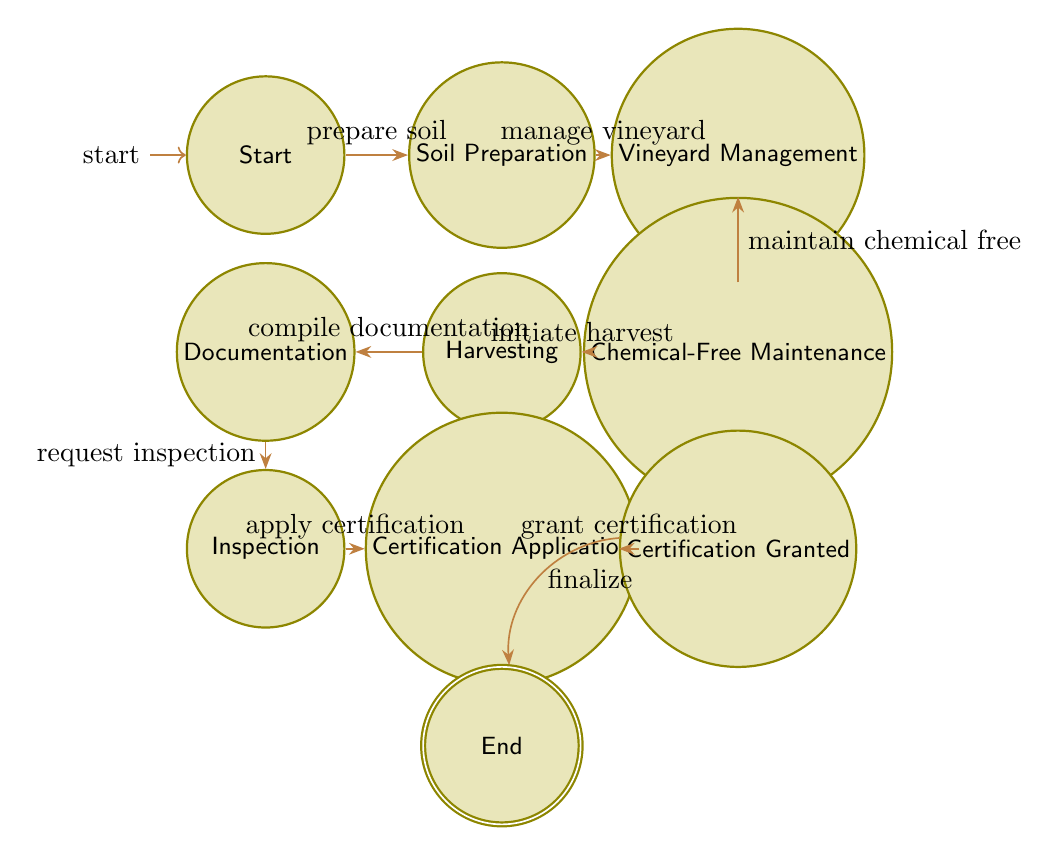What is the starting state of the workflow? The diagram indicates the initial state is labeled "Start," which is the first node in the workflow.
Answer: Start How many states are there in total? By counting all the nodes in the diagram, we find there are ten distinct states representing various steps in the organic certification compliance workflow.
Answer: 10 What follows "Chemical-Free Maintenance" in the workflow? The transition from "Chemical-Free Maintenance" leads to the next state labeled "Harvesting," as indicated by the directed arrow connecting them.
Answer: Harvesting What is the final state of the workflow? The last node in the diagram, which indicates the completion of the organic certification process, is labeled "End," thus serving as the final state.
Answer: End In which state does documentation compilation occur? The state where documentation is compiled is labeled "Documentation," and it follows the "Harvesting" state as seen in the transitions.
Answer: Documentation What is the transition name from "Inspection" to "Certification Application"? The directed edge from "Inspection" to "Certification Application" is labeled "apply certification," clearly identifying the action taken during this transition.
Answer: apply certification Which state involves the third-party inspection? The state that encompasses the third-party inspection of vineyard and processes is labeled "Inspection," as indicated by its specific designation within the workflow.
Answer: Inspection What action should be taken after "Harvesting"? After "Harvesting," it is necessary to "compile documentation," as indicated by the transition leading to the next state in the workflow.
Answer: compile documentation What is required before applying for certification? Before moving to the "Certification Application" state, it is crucial to undergo an "Inspection," as highlighted by the preceding transition in the diagram.
Answer: Inspection 